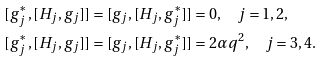Convert formula to latex. <formula><loc_0><loc_0><loc_500><loc_500>[ g ^ { * } _ { j } , [ H _ { j } , g _ { j } ] ] & = [ g _ { j } , [ H _ { j } , g ^ { * } _ { j } ] ] = 0 , \quad j = 1 , 2 , \\ [ g ^ { * } _ { j } , [ H _ { j } , g _ { j } ] ] & = [ g _ { j } , [ H _ { j } , g ^ { * } _ { j } ] ] = 2 \alpha q ^ { 2 } , \quad j = 3 , 4 .</formula> 